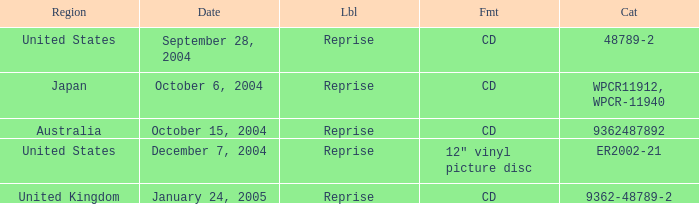Name the region for december 7, 2004 United States. 